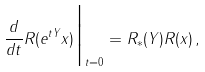<formula> <loc_0><loc_0><loc_500><loc_500>\frac { d } { d t } R ( e ^ { t Y } x ) \Big | _ { t = 0 } = R _ { \ast } ( Y ) R ( x ) \, ,</formula> 